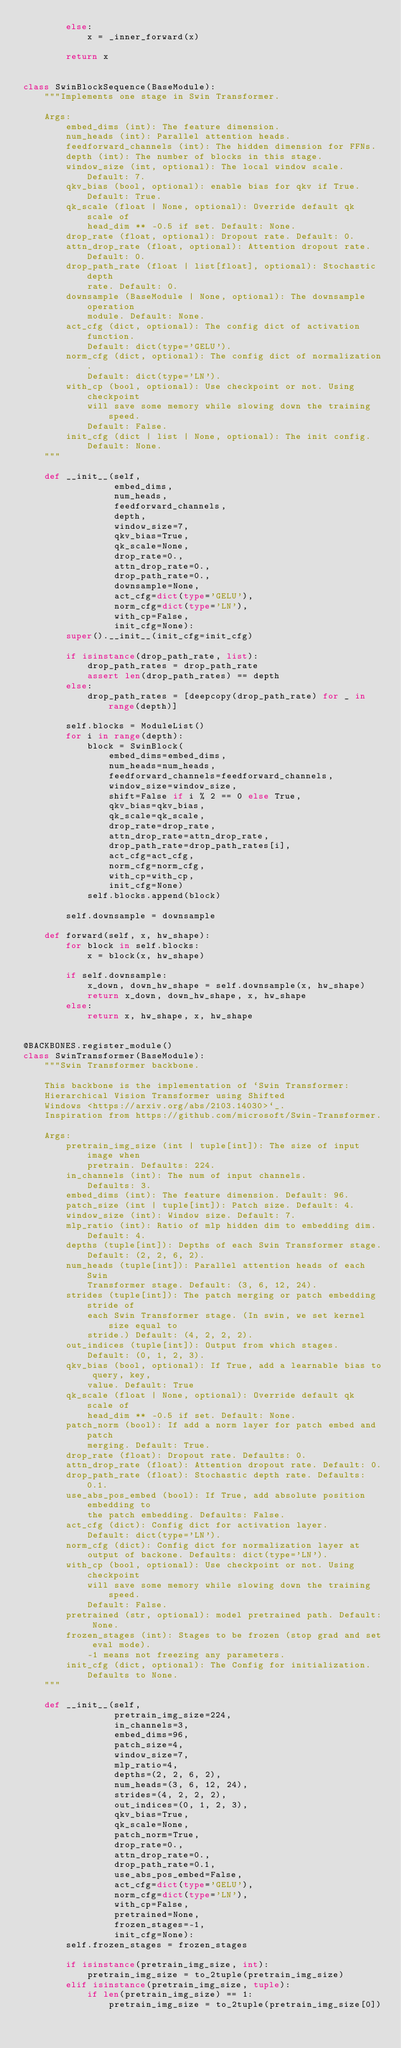Convert code to text. <code><loc_0><loc_0><loc_500><loc_500><_Python_>        else:
            x = _inner_forward(x)

        return x


class SwinBlockSequence(BaseModule):
    """Implements one stage in Swin Transformer.

    Args:
        embed_dims (int): The feature dimension.
        num_heads (int): Parallel attention heads.
        feedforward_channels (int): The hidden dimension for FFNs.
        depth (int): The number of blocks in this stage.
        window_size (int, optional): The local window scale. Default: 7.
        qkv_bias (bool, optional): enable bias for qkv if True. Default: True.
        qk_scale (float | None, optional): Override default qk scale of
            head_dim ** -0.5 if set. Default: None.
        drop_rate (float, optional): Dropout rate. Default: 0.
        attn_drop_rate (float, optional): Attention dropout rate. Default: 0.
        drop_path_rate (float | list[float], optional): Stochastic depth
            rate. Default: 0.
        downsample (BaseModule | None, optional): The downsample operation
            module. Default: None.
        act_cfg (dict, optional): The config dict of activation function.
            Default: dict(type='GELU').
        norm_cfg (dict, optional): The config dict of normalization.
            Default: dict(type='LN').
        with_cp (bool, optional): Use checkpoint or not. Using checkpoint
            will save some memory while slowing down the training speed.
            Default: False.
        init_cfg (dict | list | None, optional): The init config.
            Default: None.
    """

    def __init__(self,
                 embed_dims,
                 num_heads,
                 feedforward_channels,
                 depth,
                 window_size=7,
                 qkv_bias=True,
                 qk_scale=None,
                 drop_rate=0.,
                 attn_drop_rate=0.,
                 drop_path_rate=0.,
                 downsample=None,
                 act_cfg=dict(type='GELU'),
                 norm_cfg=dict(type='LN'),
                 with_cp=False,
                 init_cfg=None):
        super().__init__(init_cfg=init_cfg)

        if isinstance(drop_path_rate, list):
            drop_path_rates = drop_path_rate
            assert len(drop_path_rates) == depth
        else:
            drop_path_rates = [deepcopy(drop_path_rate) for _ in range(depth)]

        self.blocks = ModuleList()
        for i in range(depth):
            block = SwinBlock(
                embed_dims=embed_dims,
                num_heads=num_heads,
                feedforward_channels=feedforward_channels,
                window_size=window_size,
                shift=False if i % 2 == 0 else True,
                qkv_bias=qkv_bias,
                qk_scale=qk_scale,
                drop_rate=drop_rate,
                attn_drop_rate=attn_drop_rate,
                drop_path_rate=drop_path_rates[i],
                act_cfg=act_cfg,
                norm_cfg=norm_cfg,
                with_cp=with_cp,
                init_cfg=None)
            self.blocks.append(block)

        self.downsample = downsample

    def forward(self, x, hw_shape):
        for block in self.blocks:
            x = block(x, hw_shape)

        if self.downsample:
            x_down, down_hw_shape = self.downsample(x, hw_shape)
            return x_down, down_hw_shape, x, hw_shape
        else:
            return x, hw_shape, x, hw_shape


@BACKBONES.register_module()
class SwinTransformer(BaseModule):
    """Swin Transformer backbone.

    This backbone is the implementation of `Swin Transformer:
    Hierarchical Vision Transformer using Shifted
    Windows <https://arxiv.org/abs/2103.14030>`_.
    Inspiration from https://github.com/microsoft/Swin-Transformer.

    Args:
        pretrain_img_size (int | tuple[int]): The size of input image when
            pretrain. Defaults: 224.
        in_channels (int): The num of input channels.
            Defaults: 3.
        embed_dims (int): The feature dimension. Default: 96.
        patch_size (int | tuple[int]): Patch size. Default: 4.
        window_size (int): Window size. Default: 7.
        mlp_ratio (int): Ratio of mlp hidden dim to embedding dim.
            Default: 4.
        depths (tuple[int]): Depths of each Swin Transformer stage.
            Default: (2, 2, 6, 2).
        num_heads (tuple[int]): Parallel attention heads of each Swin
            Transformer stage. Default: (3, 6, 12, 24).
        strides (tuple[int]): The patch merging or patch embedding stride of
            each Swin Transformer stage. (In swin, we set kernel size equal to
            stride.) Default: (4, 2, 2, 2).
        out_indices (tuple[int]): Output from which stages.
            Default: (0, 1, 2, 3).
        qkv_bias (bool, optional): If True, add a learnable bias to query, key,
            value. Default: True
        qk_scale (float | None, optional): Override default qk scale of
            head_dim ** -0.5 if set. Default: None.
        patch_norm (bool): If add a norm layer for patch embed and patch
            merging. Default: True.
        drop_rate (float): Dropout rate. Defaults: 0.
        attn_drop_rate (float): Attention dropout rate. Default: 0.
        drop_path_rate (float): Stochastic depth rate. Defaults: 0.1.
        use_abs_pos_embed (bool): If True, add absolute position embedding to
            the patch embedding. Defaults: False.
        act_cfg (dict): Config dict for activation layer.
            Default: dict(type='LN').
        norm_cfg (dict): Config dict for normalization layer at
            output of backone. Defaults: dict(type='LN').
        with_cp (bool, optional): Use checkpoint or not. Using checkpoint
            will save some memory while slowing down the training speed.
            Default: False.
        pretrained (str, optional): model pretrained path. Default: None.
        frozen_stages (int): Stages to be frozen (stop grad and set eval mode).
            -1 means not freezing any parameters.
        init_cfg (dict, optional): The Config for initialization.
            Defaults to None.
    """

    def __init__(self,
                 pretrain_img_size=224,
                 in_channels=3,
                 embed_dims=96,
                 patch_size=4,
                 window_size=7,
                 mlp_ratio=4,
                 depths=(2, 2, 6, 2),
                 num_heads=(3, 6, 12, 24),
                 strides=(4, 2, 2, 2),
                 out_indices=(0, 1, 2, 3),
                 qkv_bias=True,
                 qk_scale=None,
                 patch_norm=True,
                 drop_rate=0.,
                 attn_drop_rate=0.,
                 drop_path_rate=0.1,
                 use_abs_pos_embed=False,
                 act_cfg=dict(type='GELU'),
                 norm_cfg=dict(type='LN'),
                 with_cp=False,
                 pretrained=None,
                 frozen_stages=-1,
                 init_cfg=None):
        self.frozen_stages = frozen_stages

        if isinstance(pretrain_img_size, int):
            pretrain_img_size = to_2tuple(pretrain_img_size)
        elif isinstance(pretrain_img_size, tuple):
            if len(pretrain_img_size) == 1:
                pretrain_img_size = to_2tuple(pretrain_img_size[0])</code> 